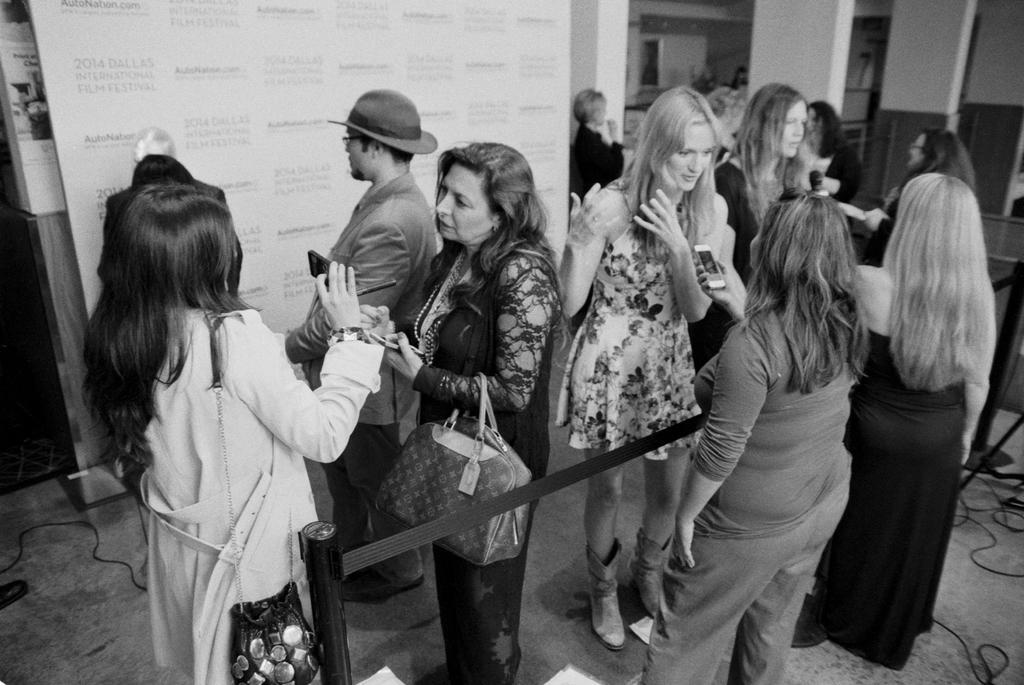Can you describe this image briefly? This is a black and white pic. Here we can see a man standing on the floor and there is a hat on his head and rest all are women standing on the floor. On the left we can see two women carrying bags on their hand and shoulder and among them few woman are holding mobiles in their hands and we can see hoarding,wall,pillars and cables on the floor. 